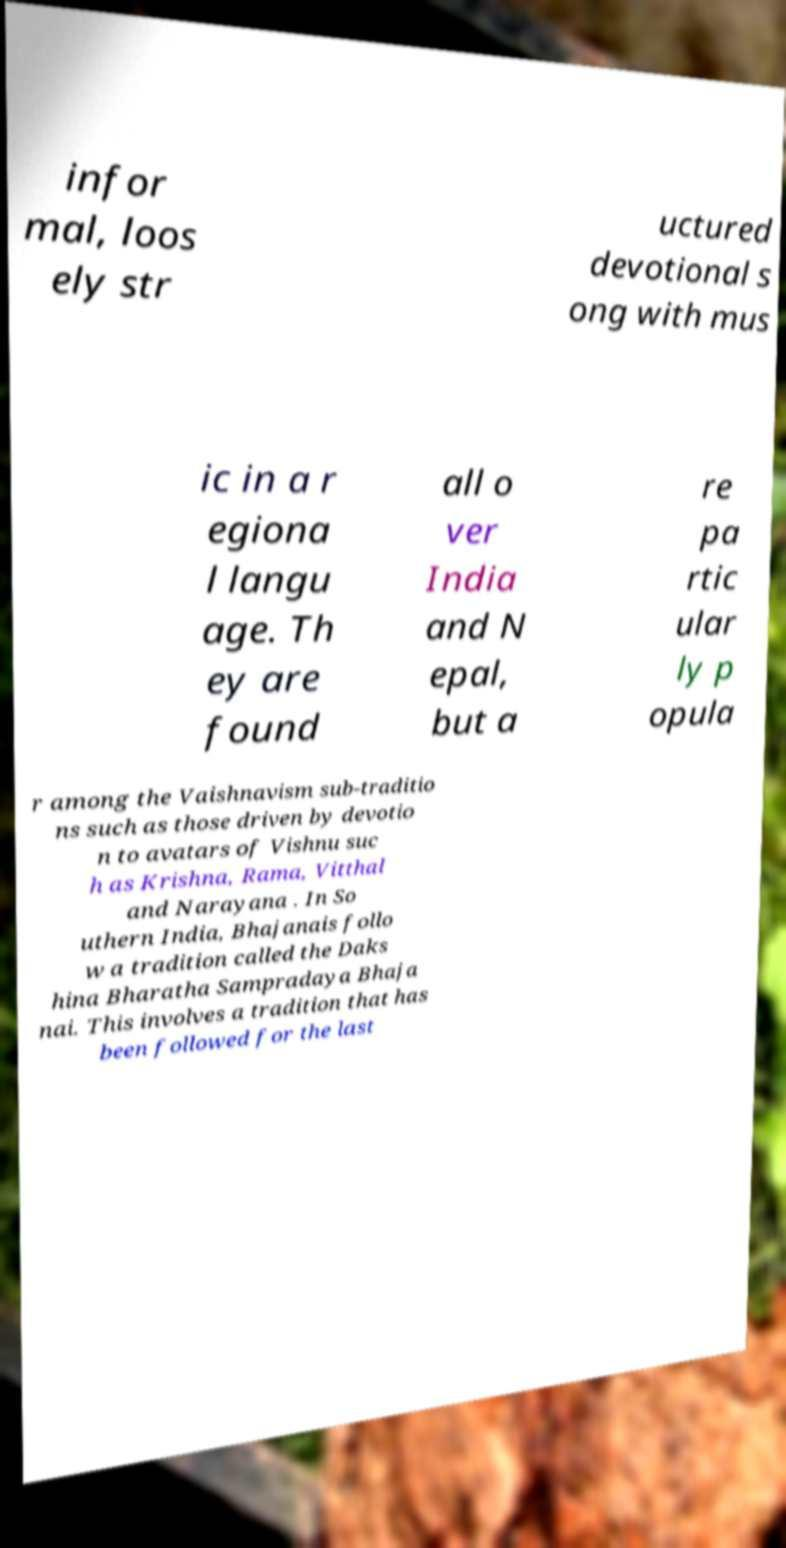Could you assist in decoding the text presented in this image and type it out clearly? infor mal, loos ely str uctured devotional s ong with mus ic in a r egiona l langu age. Th ey are found all o ver India and N epal, but a re pa rtic ular ly p opula r among the Vaishnavism sub-traditio ns such as those driven by devotio n to avatars of Vishnu suc h as Krishna, Rama, Vitthal and Narayana . In So uthern India, Bhajanais follo w a tradition called the Daks hina Bharatha Sampradaya Bhaja nai. This involves a tradition that has been followed for the last 